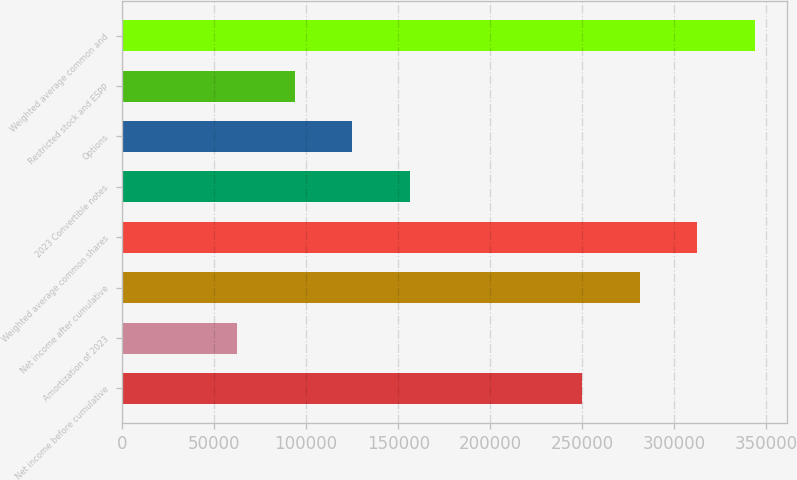Convert chart. <chart><loc_0><loc_0><loc_500><loc_500><bar_chart><fcel>Net income before cumulative<fcel>Amortization of 2023<fcel>Net income after cumulative<fcel>Weighted average common shares<fcel>2023 Convertible notes<fcel>Options<fcel>Restricted stock and ESPP<fcel>Weighted average common and<nl><fcel>249966<fcel>62491.8<fcel>281211<fcel>312457<fcel>156229<fcel>124983<fcel>93737.5<fcel>343703<nl></chart> 